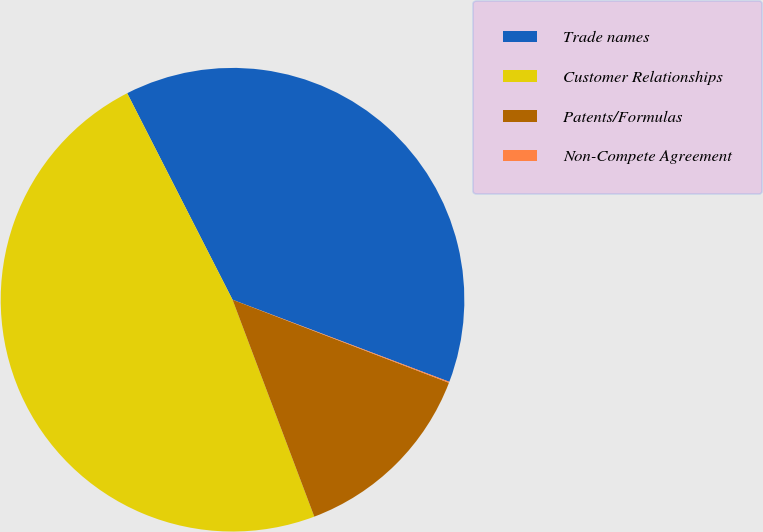Convert chart. <chart><loc_0><loc_0><loc_500><loc_500><pie_chart><fcel>Trade names<fcel>Customer Relationships<fcel>Patents/Formulas<fcel>Non-Compete Agreement<nl><fcel>38.27%<fcel>48.23%<fcel>13.43%<fcel>0.07%<nl></chart> 